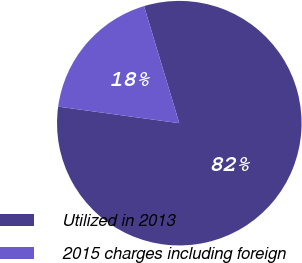<chart> <loc_0><loc_0><loc_500><loc_500><pie_chart><fcel>Utilized in 2013<fcel>2015 charges including foreign<nl><fcel>81.82%<fcel>18.18%<nl></chart> 